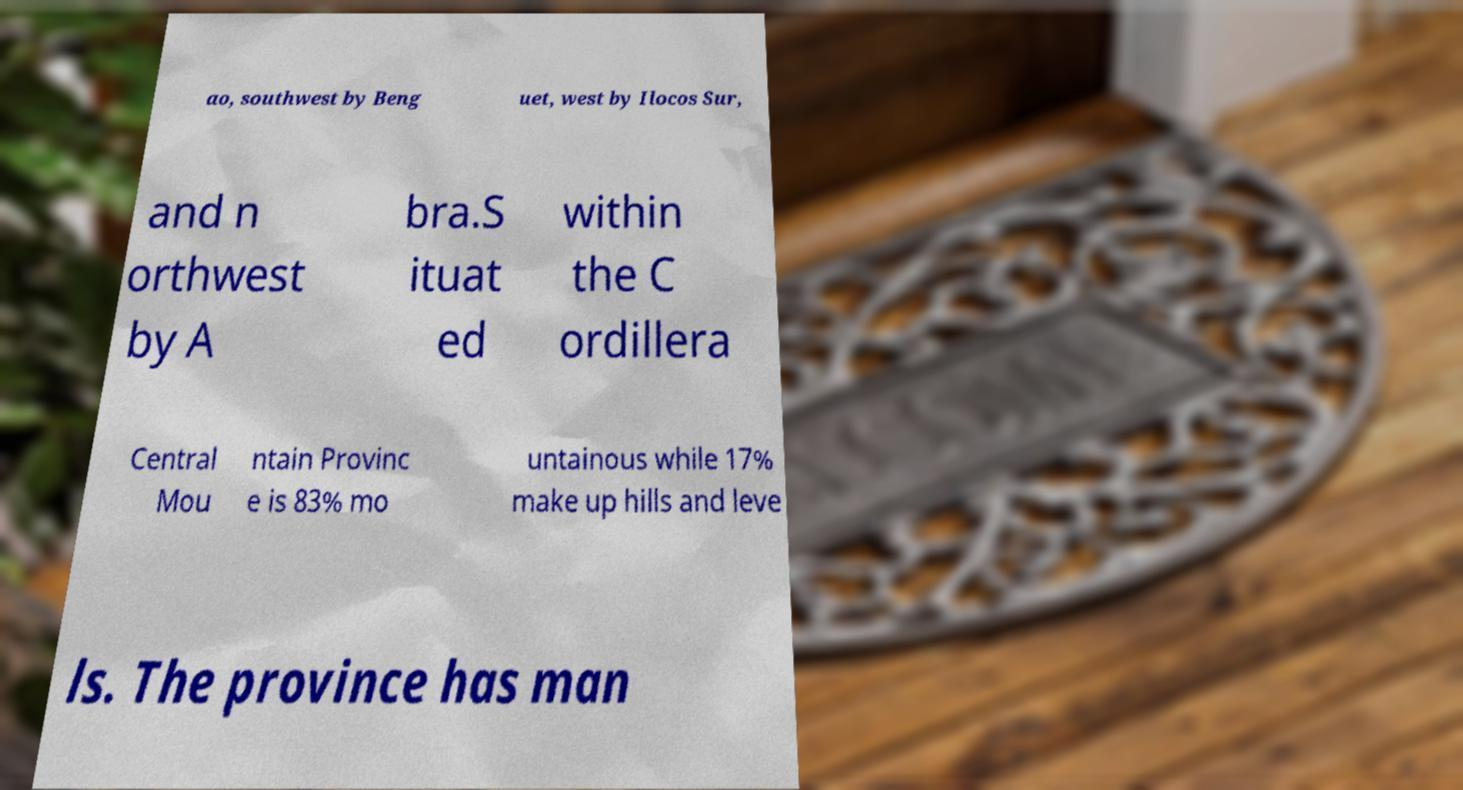Could you extract and type out the text from this image? ao, southwest by Beng uet, west by Ilocos Sur, and n orthwest by A bra.S ituat ed within the C ordillera Central Mou ntain Provinc e is 83% mo untainous while 17% make up hills and leve ls. The province has man 